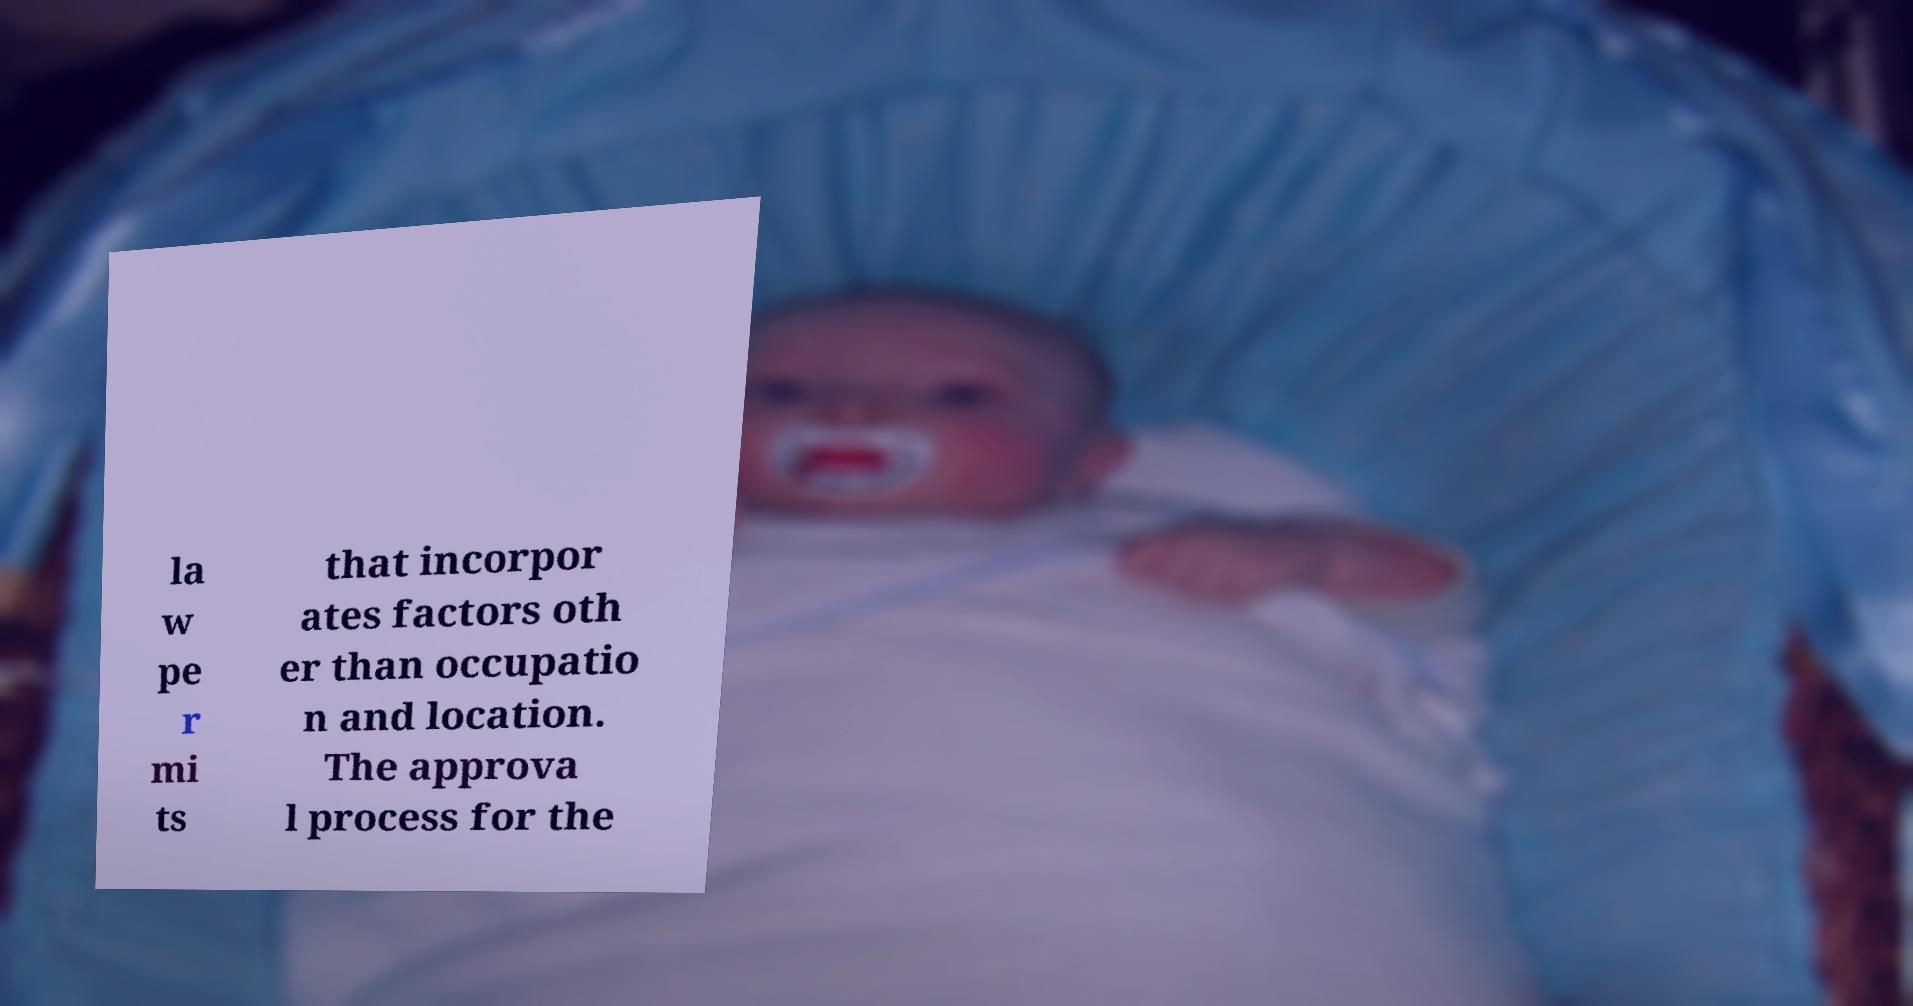I need the written content from this picture converted into text. Can you do that? la w pe r mi ts that incorpor ates factors oth er than occupatio n and location. The approva l process for the 